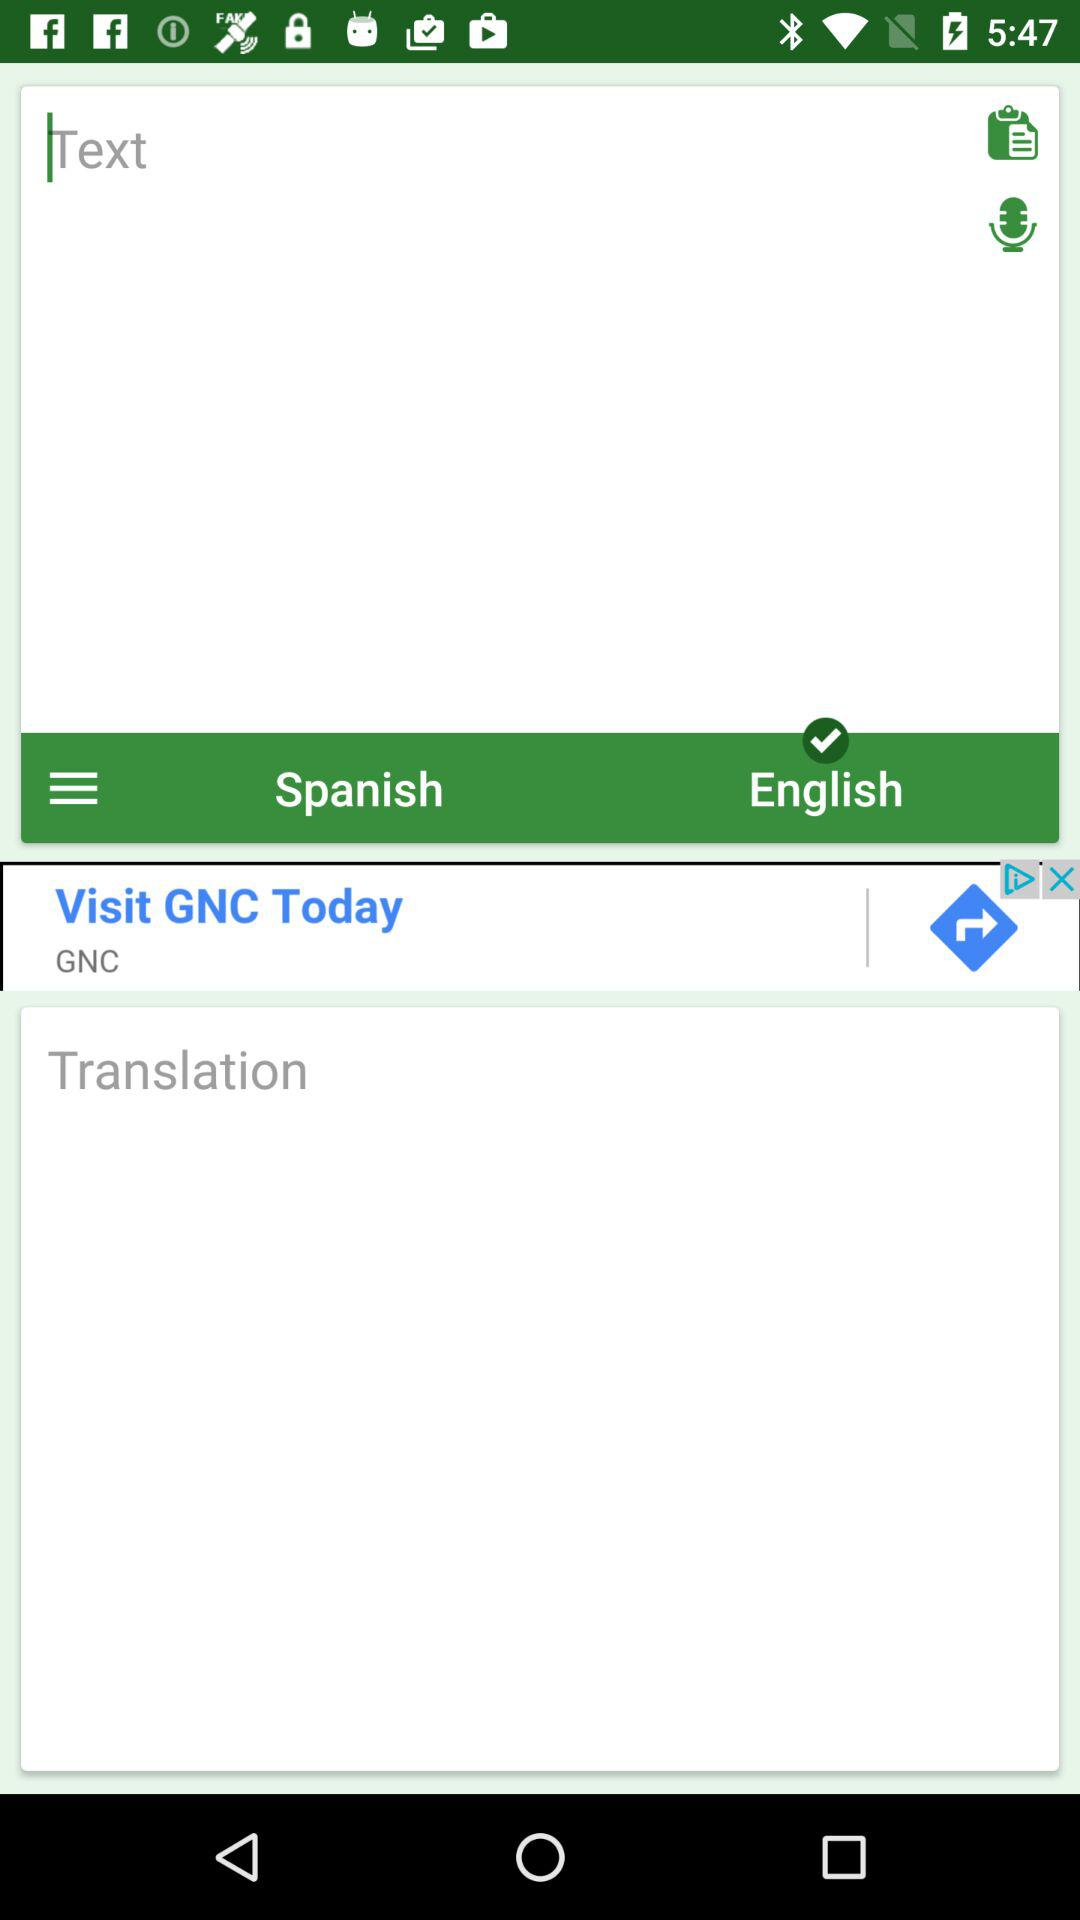How many text inputs are on the screen?
Answer the question using a single word or phrase. 2 